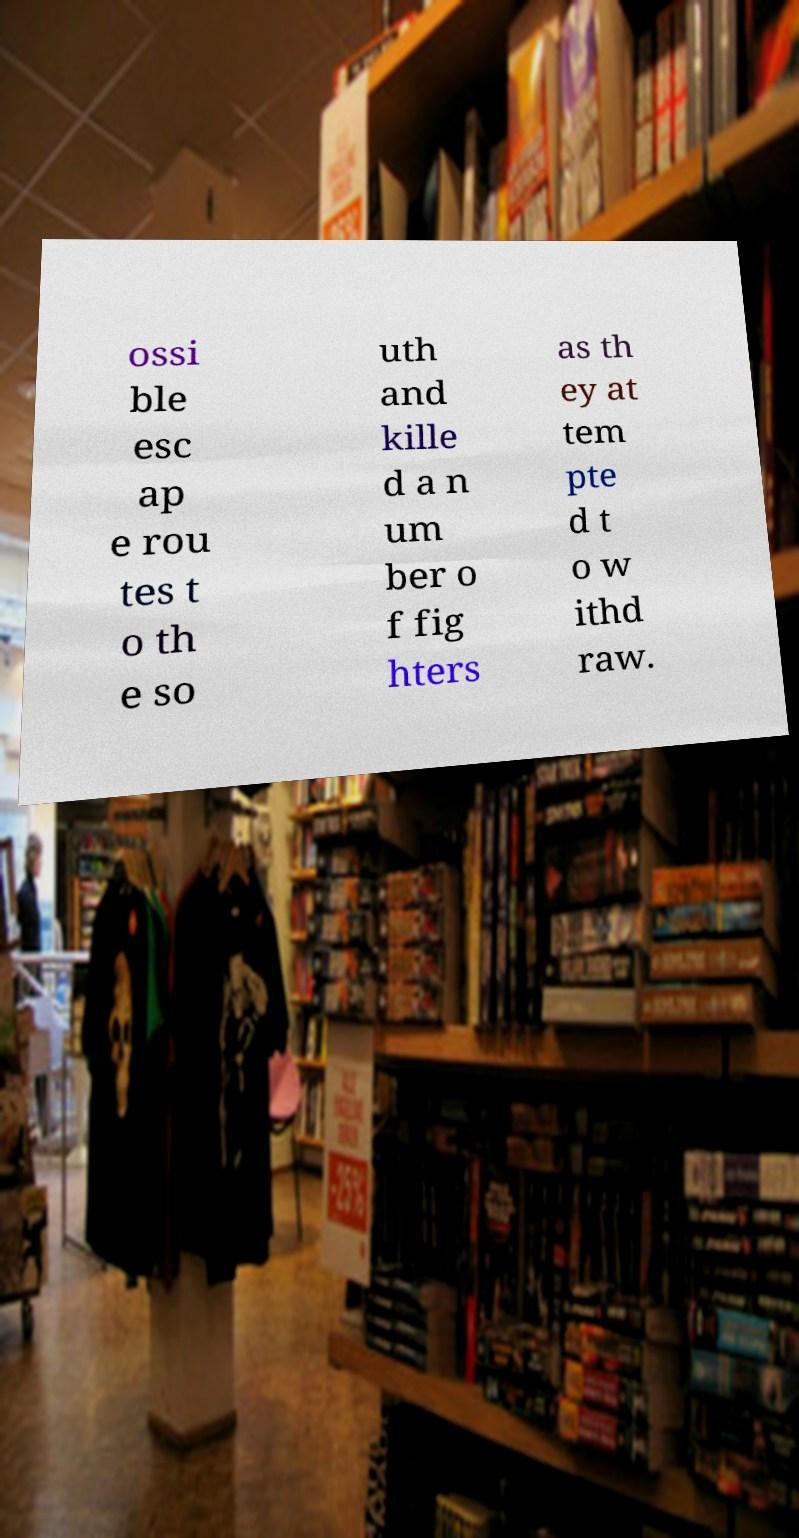Could you assist in decoding the text presented in this image and type it out clearly? ossi ble esc ap e rou tes t o th e so uth and kille d a n um ber o f fig hters as th ey at tem pte d t o w ithd raw. 